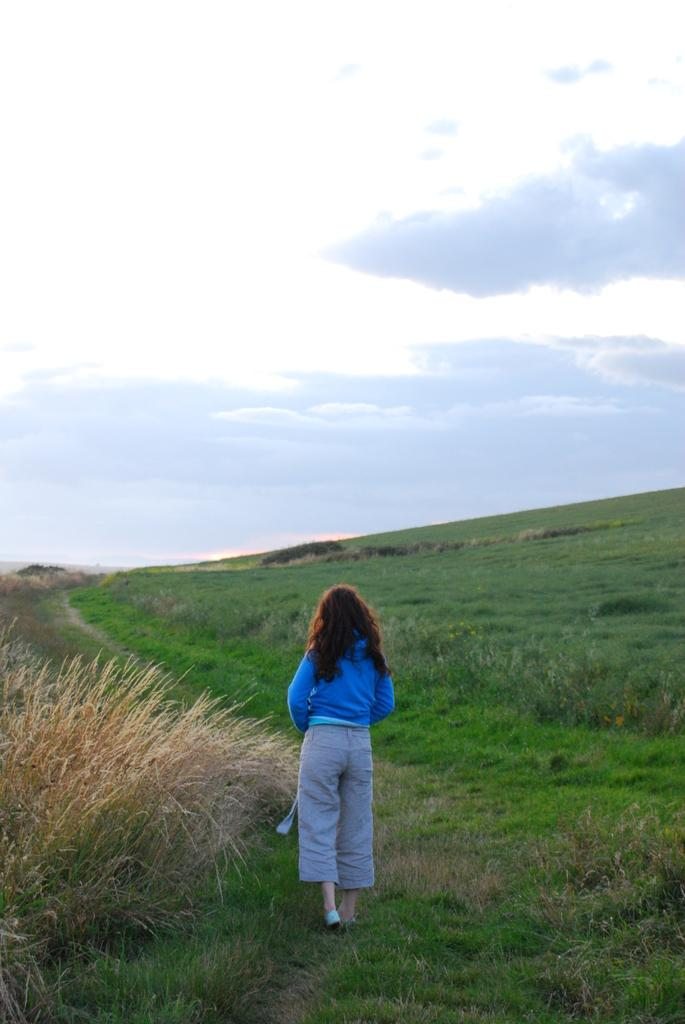What is the main subject of the image? There is a girl walking in the image. What type of terrain is visible in the image? There is grass visible in the image. What can be seen in the background of the image? There is sky visible in the background of the image. What is the condition of the sky in the image? Clouds are present in the sky. What type of furniture can be seen in the image? There is no furniture present in the image; it features a girl walking on grass with a sky background. 